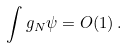Convert formula to latex. <formula><loc_0><loc_0><loc_500><loc_500>\int g _ { N } \psi = O ( 1 ) \, .</formula> 